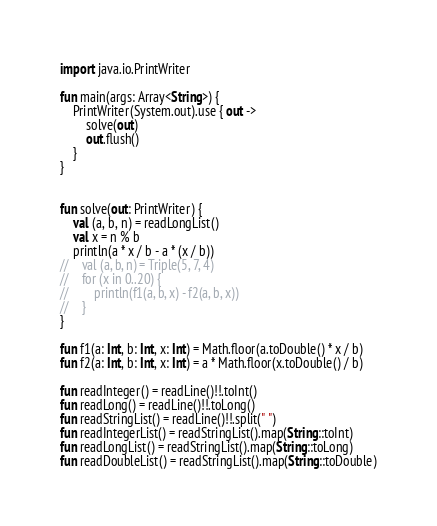Convert code to text. <code><loc_0><loc_0><loc_500><loc_500><_Kotlin_>import java.io.PrintWriter

fun main(args: Array<String>) {
    PrintWriter(System.out).use { out ->
        solve(out)
        out.flush()
    }
}


fun solve(out: PrintWriter) {
    val (a, b, n) = readLongList()
    val x = n % b
    println(a * x / b - a * (x / b))
//    val (a, b, n) = Triple(5, 7, 4)
//    for (x in 0..20) {
//        println(f1(a, b, x) - f2(a, b, x))
//    }
}

fun f1(a: Int, b: Int, x: Int) = Math.floor(a.toDouble() * x / b)
fun f2(a: Int, b: Int, x: Int) = a * Math.floor(x.toDouble() / b)

fun readInteger() = readLine()!!.toInt()
fun readLong() = readLine()!!.toLong()
fun readStringList() = readLine()!!.split(" ")
fun readIntegerList() = readStringList().map(String::toInt)
fun readLongList() = readStringList().map(String::toLong)
fun readDoubleList() = readStringList().map(String::toDouble)
</code> 